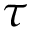Convert formula to latex. <formula><loc_0><loc_0><loc_500><loc_500>\tau</formula> 